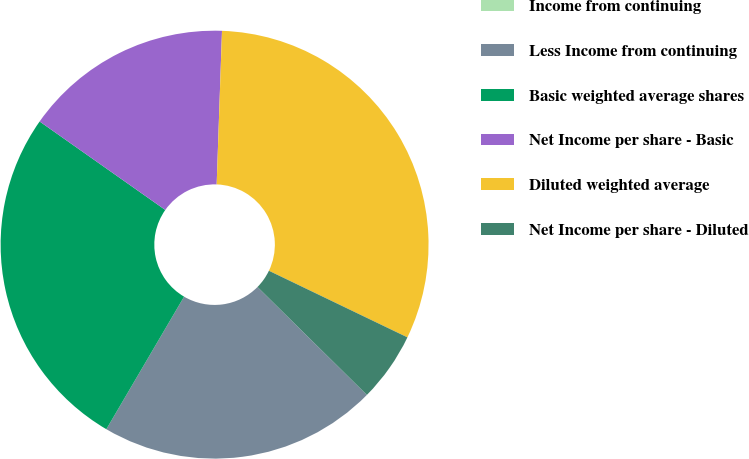Convert chart. <chart><loc_0><loc_0><loc_500><loc_500><pie_chart><fcel>Income from continuing<fcel>Less Income from continuing<fcel>Basic weighted average shares<fcel>Net Income per share - Basic<fcel>Diluted weighted average<fcel>Net Income per share - Diluted<nl><fcel>0.0%<fcel>21.05%<fcel>26.32%<fcel>15.79%<fcel>31.58%<fcel>5.26%<nl></chart> 